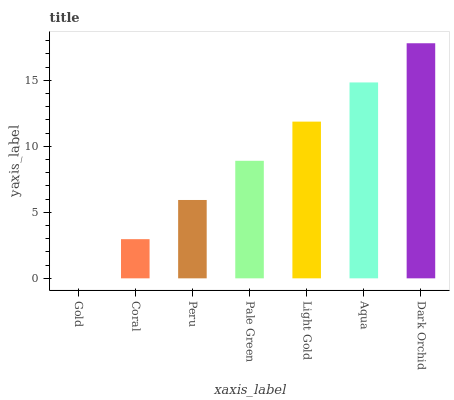Is Gold the minimum?
Answer yes or no. Yes. Is Dark Orchid the maximum?
Answer yes or no. Yes. Is Coral the minimum?
Answer yes or no. No. Is Coral the maximum?
Answer yes or no. No. Is Coral greater than Gold?
Answer yes or no. Yes. Is Gold less than Coral?
Answer yes or no. Yes. Is Gold greater than Coral?
Answer yes or no. No. Is Coral less than Gold?
Answer yes or no. No. Is Pale Green the high median?
Answer yes or no. Yes. Is Pale Green the low median?
Answer yes or no. Yes. Is Dark Orchid the high median?
Answer yes or no. No. Is Aqua the low median?
Answer yes or no. No. 